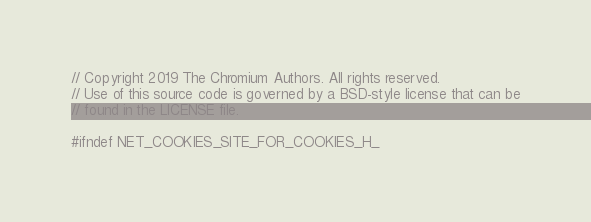<code> <loc_0><loc_0><loc_500><loc_500><_C_>// Copyright 2019 The Chromium Authors. All rights reserved.
// Use of this source code is governed by a BSD-style license that can be
// found in the LICENSE file.

#ifndef NET_COOKIES_SITE_FOR_COOKIES_H_</code> 